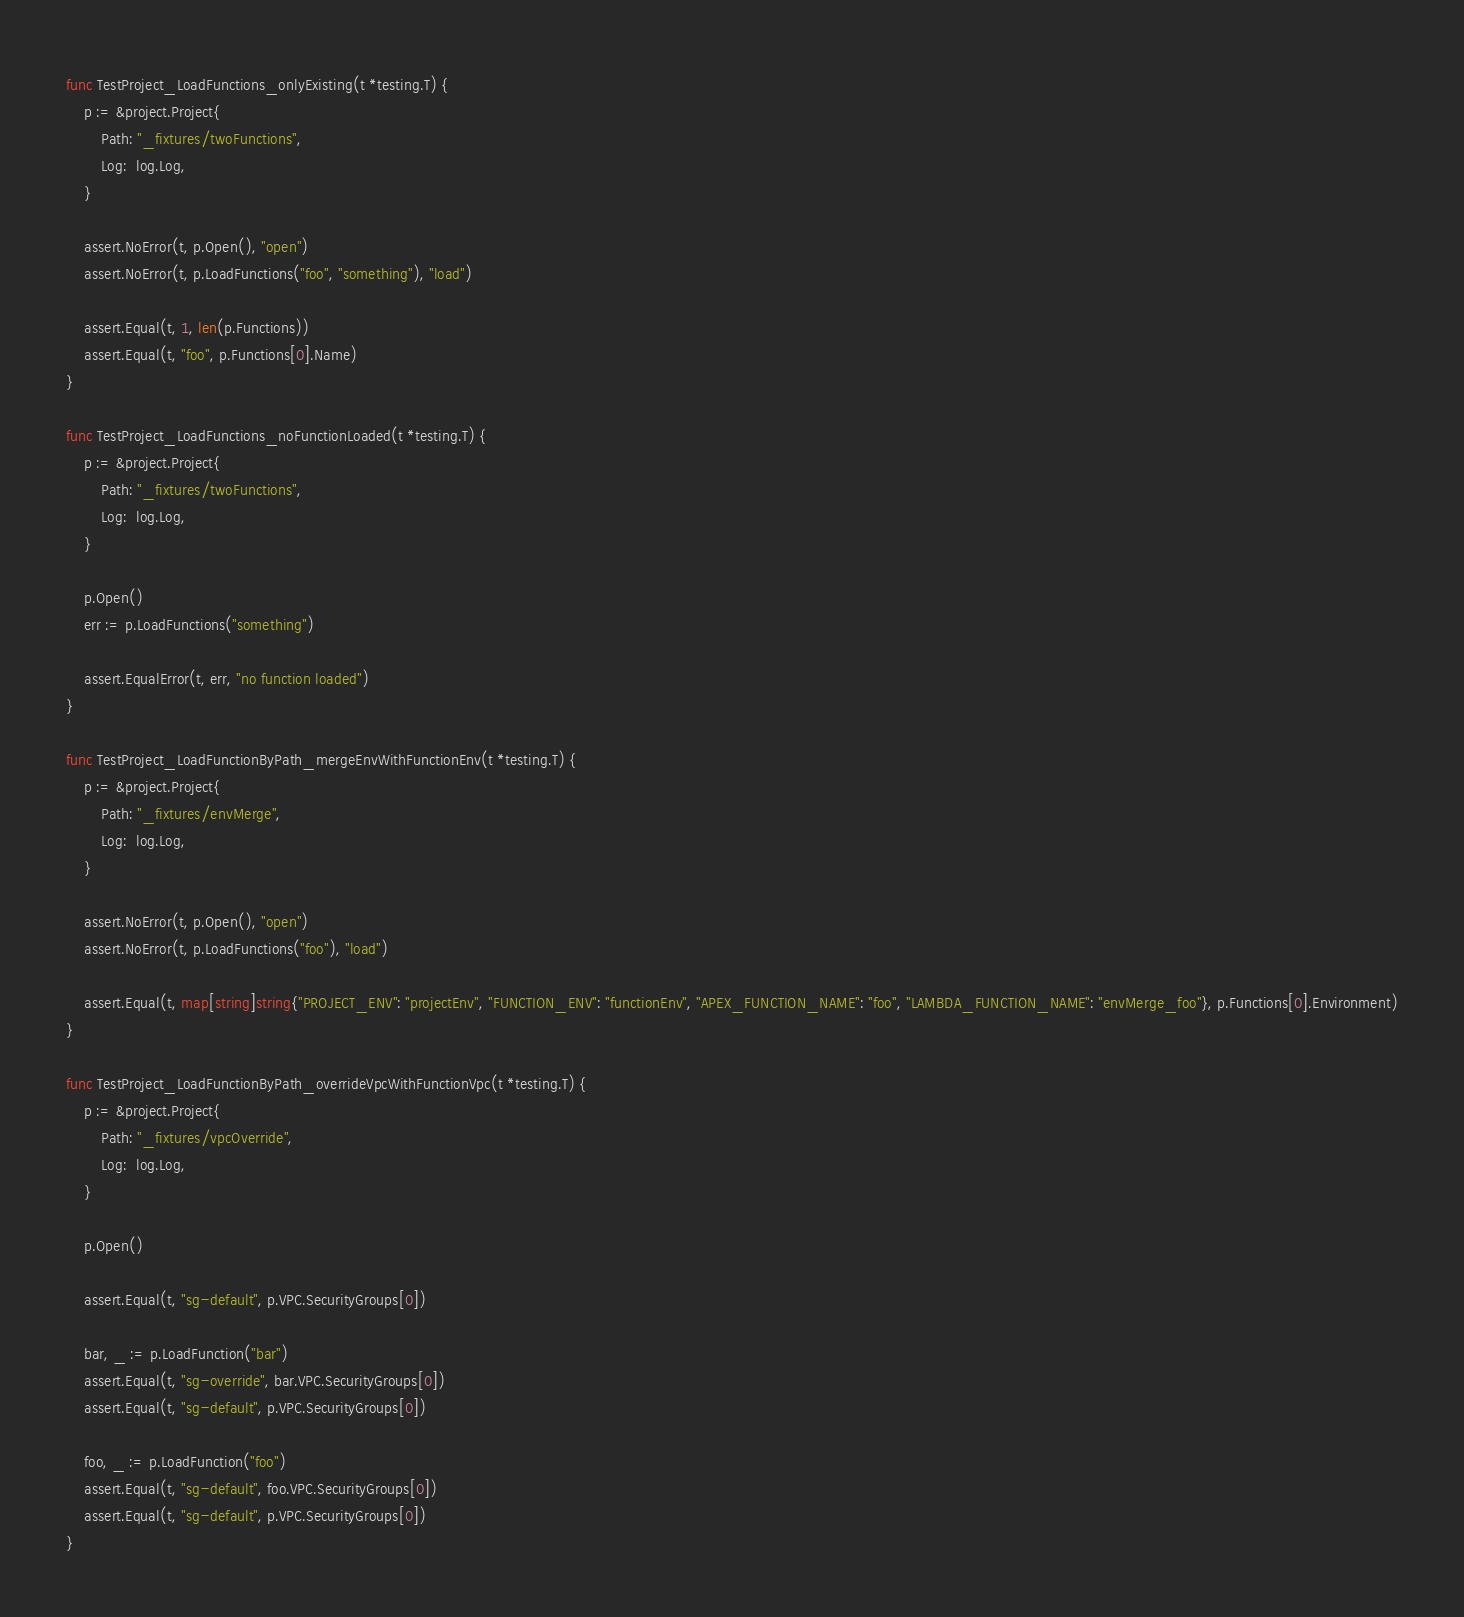Convert code to text. <code><loc_0><loc_0><loc_500><loc_500><_Go_>
func TestProject_LoadFunctions_onlyExisting(t *testing.T) {
	p := &project.Project{
		Path: "_fixtures/twoFunctions",
		Log:  log.Log,
	}

	assert.NoError(t, p.Open(), "open")
	assert.NoError(t, p.LoadFunctions("foo", "something"), "load")

	assert.Equal(t, 1, len(p.Functions))
	assert.Equal(t, "foo", p.Functions[0].Name)
}

func TestProject_LoadFunctions_noFunctionLoaded(t *testing.T) {
	p := &project.Project{
		Path: "_fixtures/twoFunctions",
		Log:  log.Log,
	}

	p.Open()
	err := p.LoadFunctions("something")

	assert.EqualError(t, err, "no function loaded")
}

func TestProject_LoadFunctionByPath_mergeEnvWithFunctionEnv(t *testing.T) {
	p := &project.Project{
		Path: "_fixtures/envMerge",
		Log:  log.Log,
	}

	assert.NoError(t, p.Open(), "open")
	assert.NoError(t, p.LoadFunctions("foo"), "load")

	assert.Equal(t, map[string]string{"PROJECT_ENV": "projectEnv", "FUNCTION_ENV": "functionEnv", "APEX_FUNCTION_NAME": "foo", "LAMBDA_FUNCTION_NAME": "envMerge_foo"}, p.Functions[0].Environment)
}

func TestProject_LoadFunctionByPath_overrideVpcWithFunctionVpc(t *testing.T) {
	p := &project.Project{
		Path: "_fixtures/vpcOverride",
		Log:  log.Log,
	}

	p.Open()

	assert.Equal(t, "sg-default", p.VPC.SecurityGroups[0])

	bar, _ := p.LoadFunction("bar")
	assert.Equal(t, "sg-override", bar.VPC.SecurityGroups[0])
	assert.Equal(t, "sg-default", p.VPC.SecurityGroups[0])

	foo, _ := p.LoadFunction("foo")
	assert.Equal(t, "sg-default", foo.VPC.SecurityGroups[0])
	assert.Equal(t, "sg-default", p.VPC.SecurityGroups[0])
}
</code> 